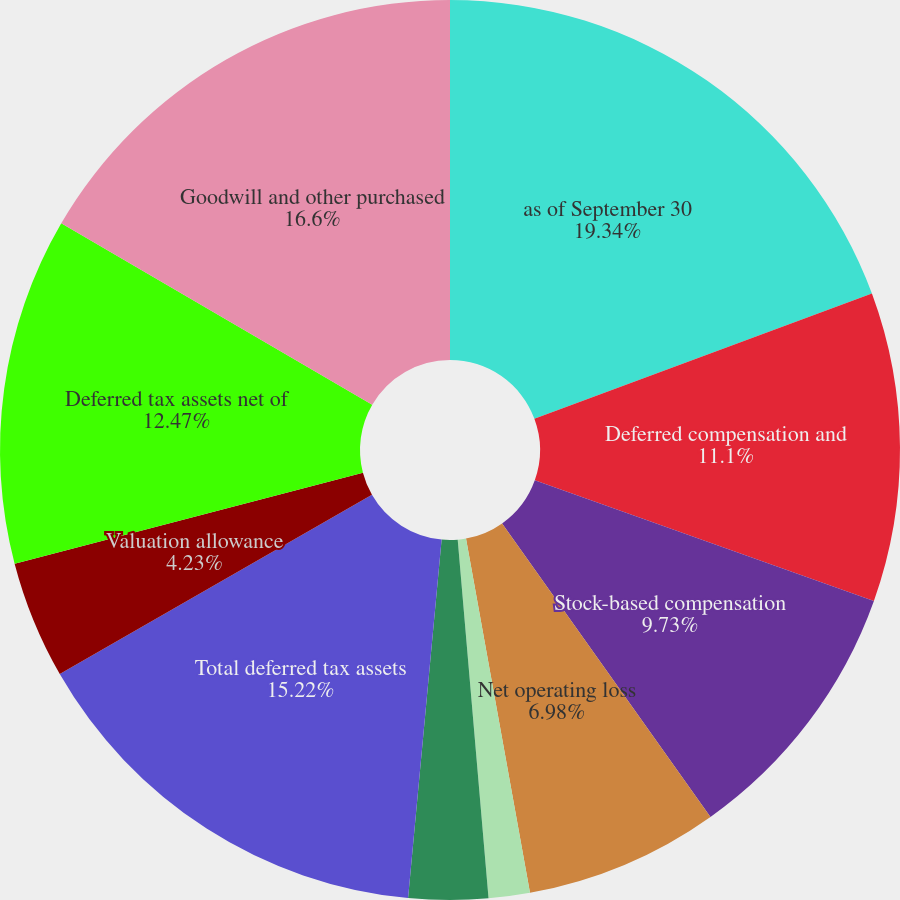Convert chart. <chart><loc_0><loc_0><loc_500><loc_500><pie_chart><fcel>as of September 30<fcel>Deferred compensation and<fcel>Stock-based compensation<fcel>Net operating loss<fcel>Tax benefit for uncertain tax<fcel>Other<fcel>Total deferred tax assets<fcel>Valuation allowance<fcel>Deferred tax assets net of<fcel>Goodwill and other purchased<nl><fcel>19.35%<fcel>11.1%<fcel>9.73%<fcel>6.98%<fcel>1.48%<fcel>2.85%<fcel>15.22%<fcel>4.23%<fcel>12.47%<fcel>16.6%<nl></chart> 